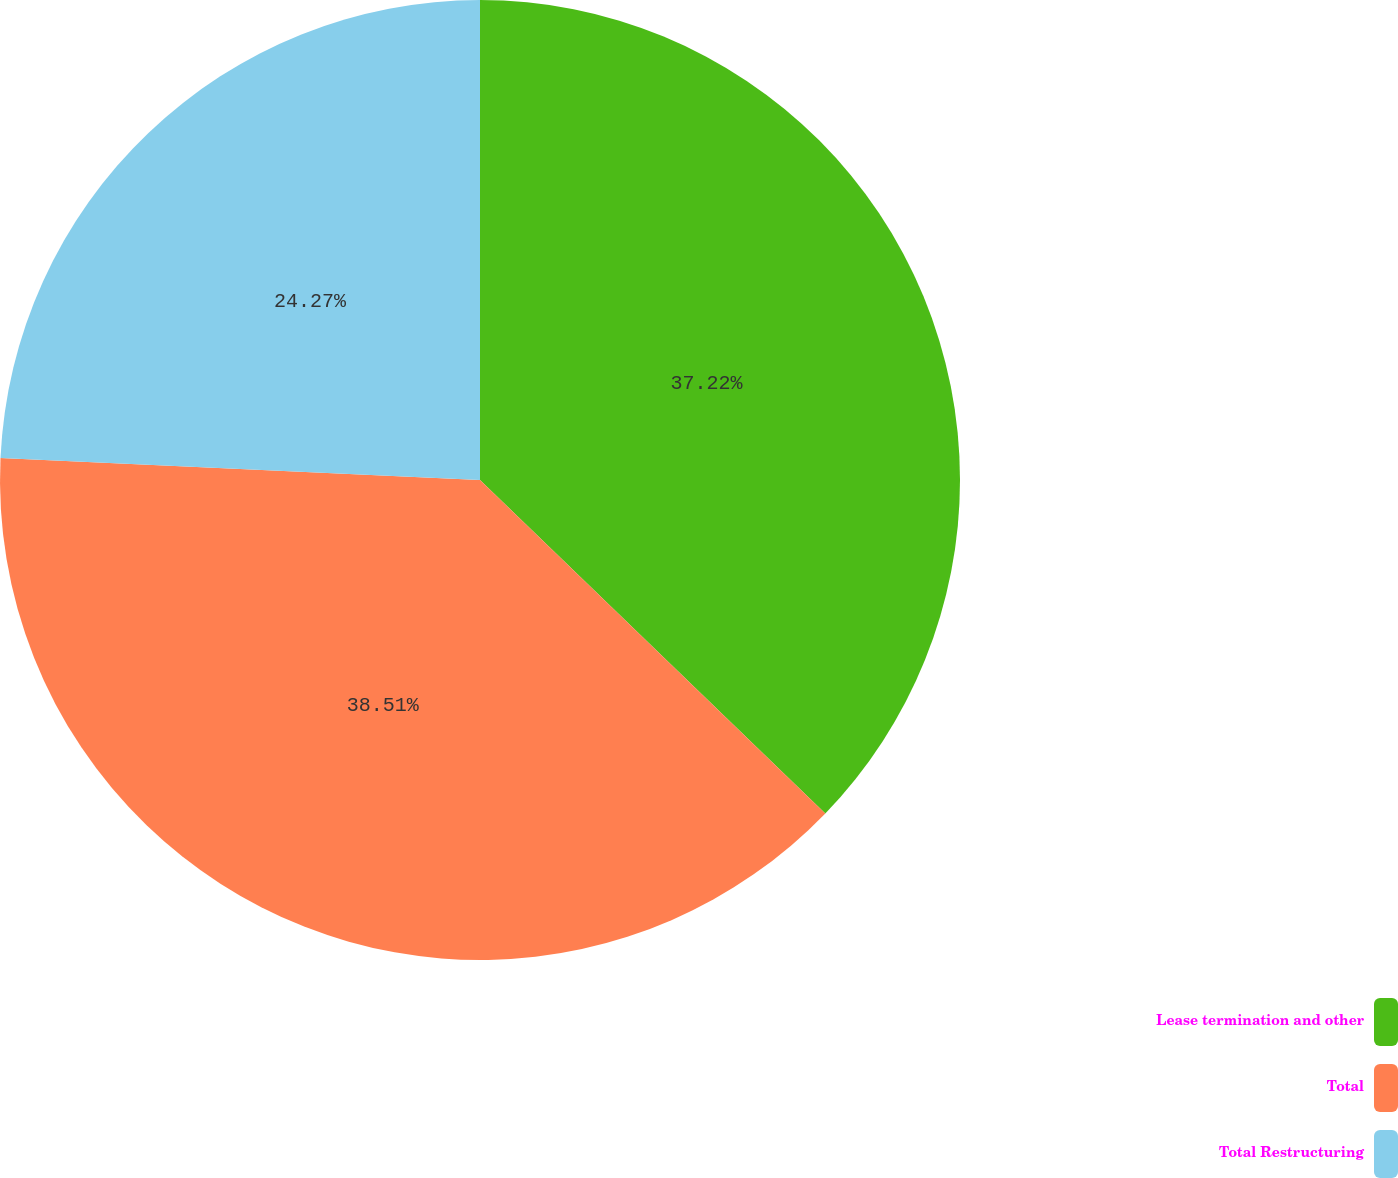Convert chart to OTSL. <chart><loc_0><loc_0><loc_500><loc_500><pie_chart><fcel>Lease termination and other<fcel>Total<fcel>Total Restructuring<nl><fcel>37.22%<fcel>38.51%<fcel>24.27%<nl></chart> 